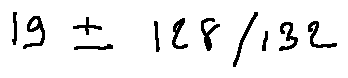Convert formula to latex. <formula><loc_0><loc_0><loc_500><loc_500>1 9 \pm 1 2 8 / 1 3 2</formula> 